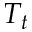Convert formula to latex. <formula><loc_0><loc_0><loc_500><loc_500>T _ { t }</formula> 